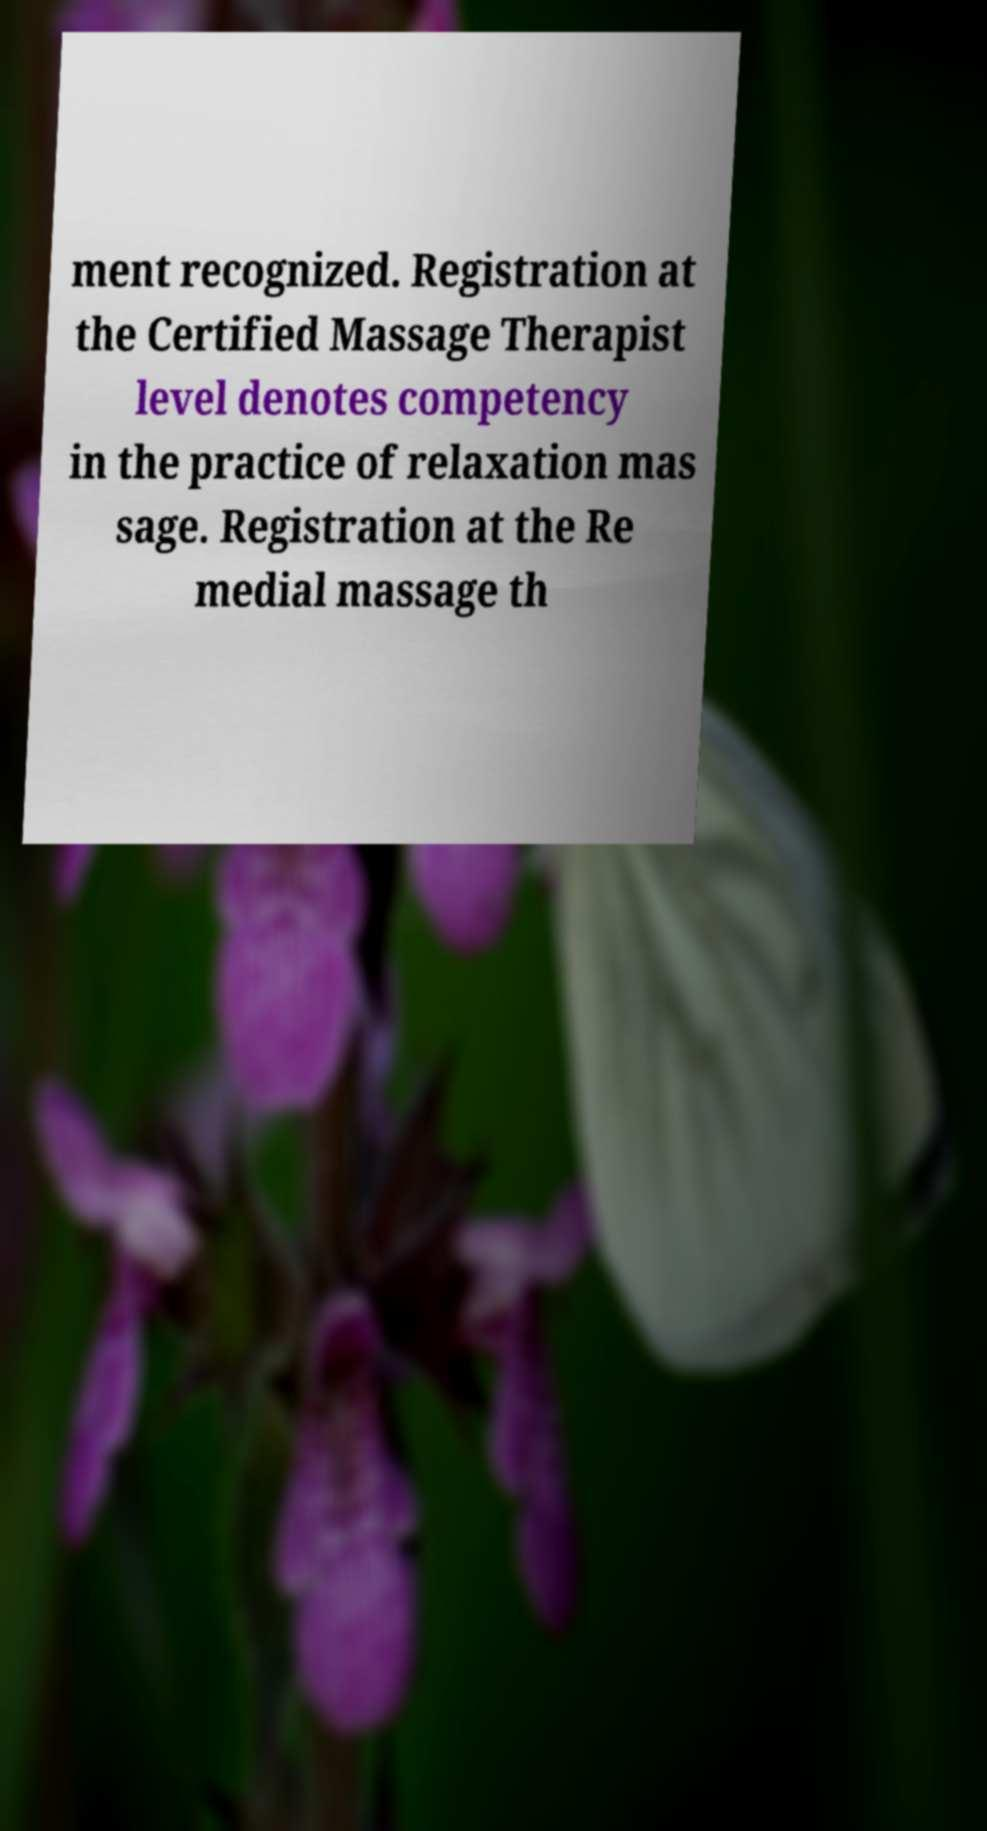What messages or text are displayed in this image? I need them in a readable, typed format. ment recognized. Registration at the Certified Massage Therapist level denotes competency in the practice of relaxation mas sage. Registration at the Re medial massage th 